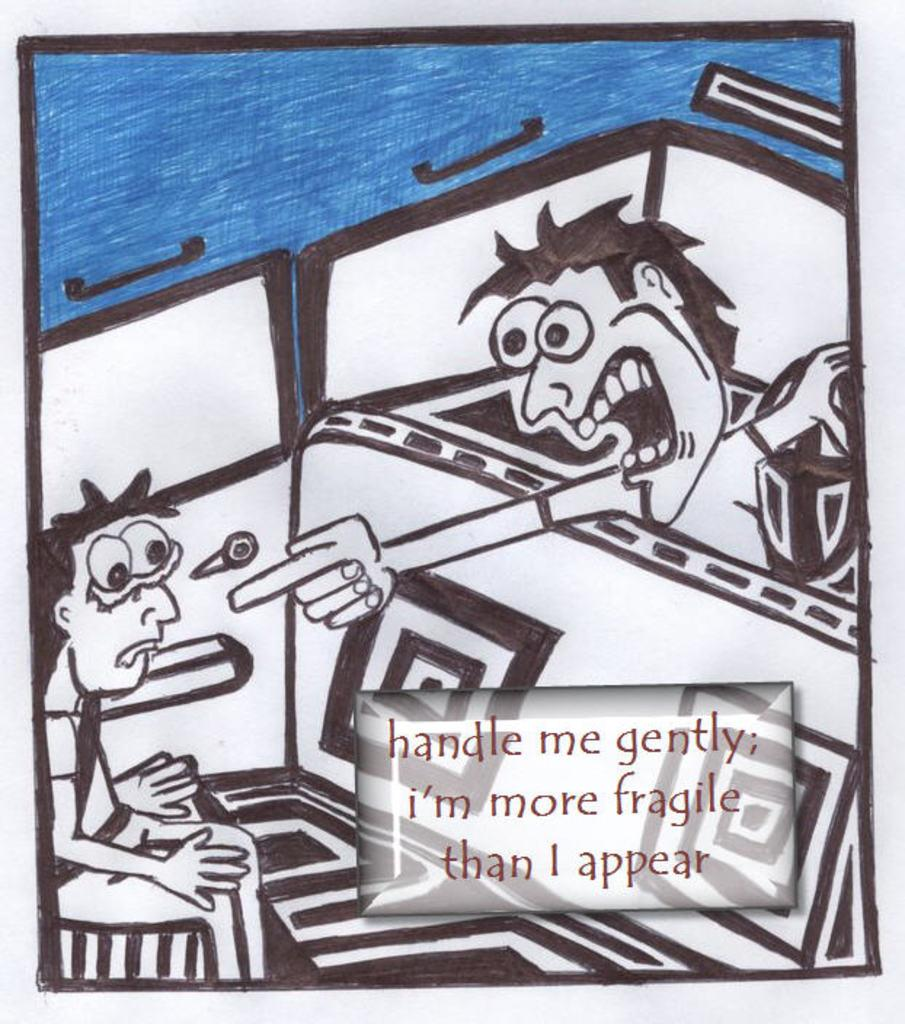<image>
Summarize the visual content of the image. a person yelling at another one with the word fragile on it 